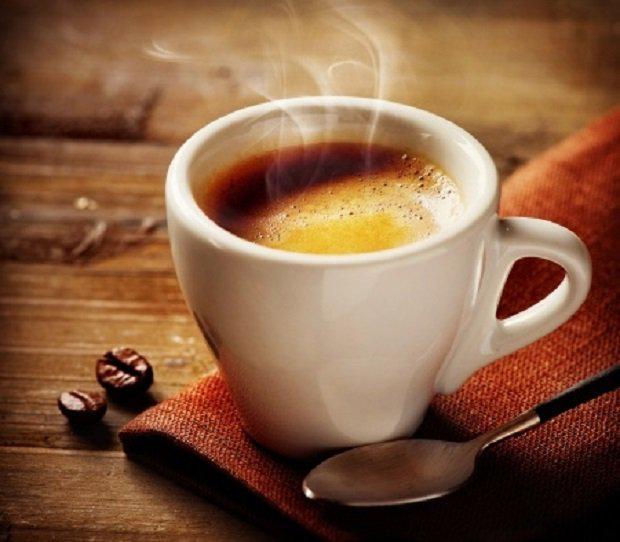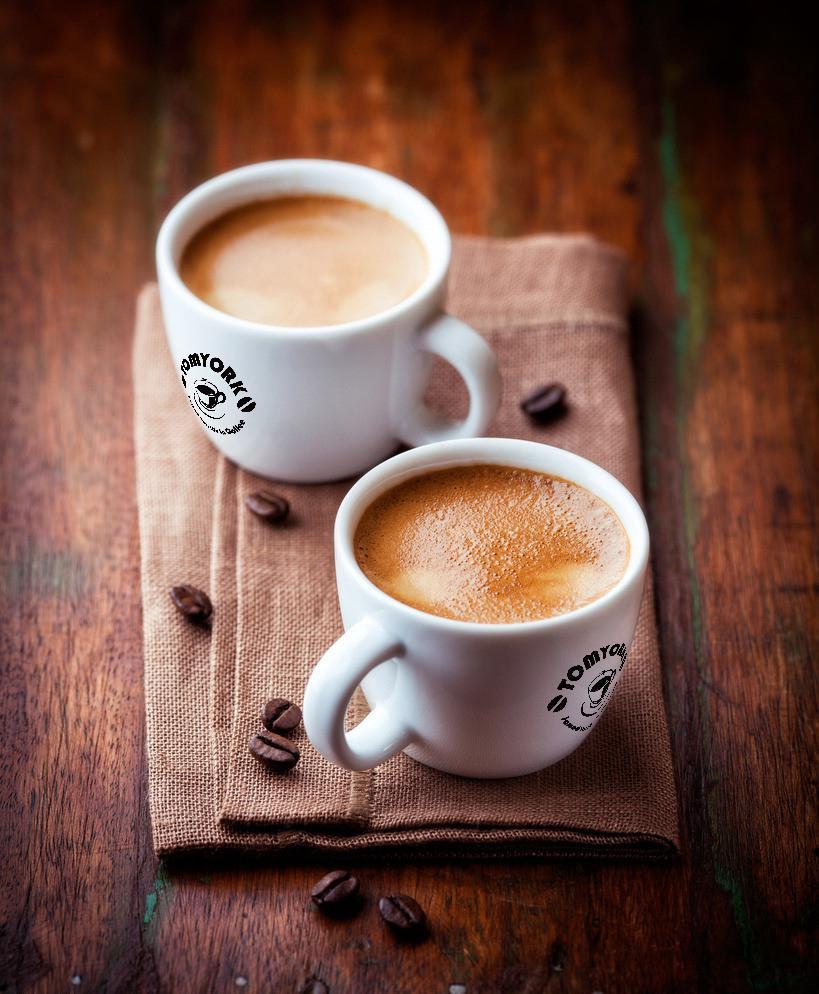The first image is the image on the left, the second image is the image on the right. Considering the images on both sides, is "A pair of white cups sit on a folded woven beige cloth with a scattering of coffee beans on it." valid? Answer yes or no. Yes. 